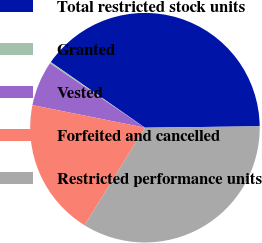Convert chart to OTSL. <chart><loc_0><loc_0><loc_500><loc_500><pie_chart><fcel>Total restricted stock units<fcel>Granted<fcel>Vested<fcel>Forfeited and cancelled<fcel>Restricted performance units<nl><fcel>40.12%<fcel>0.21%<fcel>6.32%<fcel>19.34%<fcel>34.01%<nl></chart> 